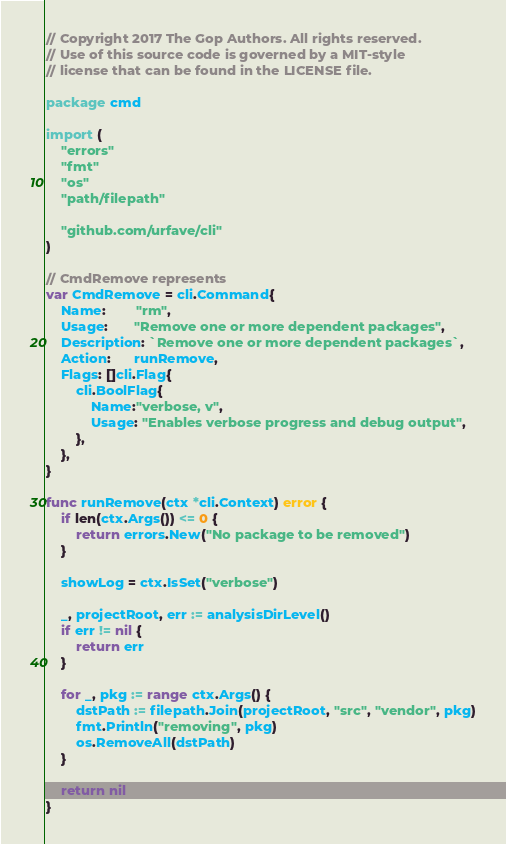<code> <loc_0><loc_0><loc_500><loc_500><_Go_>// Copyright 2017 The Gop Authors. All rights reserved.
// Use of this source code is governed by a MIT-style
// license that can be found in the LICENSE file.

package cmd

import (
	"errors"
	"fmt"
	"os"
	"path/filepath"

	"github.com/urfave/cli"
)

// CmdRemove represents
var CmdRemove = cli.Command{
	Name:        "rm",
	Usage:       "Remove one or more dependent packages",
	Description: `Remove one or more dependent packages`,
	Action:      runRemove,
	Flags: []cli.Flag{
		cli.BoolFlag{
			Name:"verbose, v",
			Usage: "Enables verbose progress and debug output",
		},
	},
}

func runRemove(ctx *cli.Context) error {
	if len(ctx.Args()) <= 0 {
		return errors.New("No package to be removed")
	}

	showLog = ctx.IsSet("verbose")

	_, projectRoot, err := analysisDirLevel()
	if err != nil {
		return err
	}

	for _, pkg := range ctx.Args() {
		dstPath := filepath.Join(projectRoot, "src", "vendor", pkg)
		fmt.Println("removing", pkg)
		os.RemoveAll(dstPath)
	}

	return nil
}
</code> 